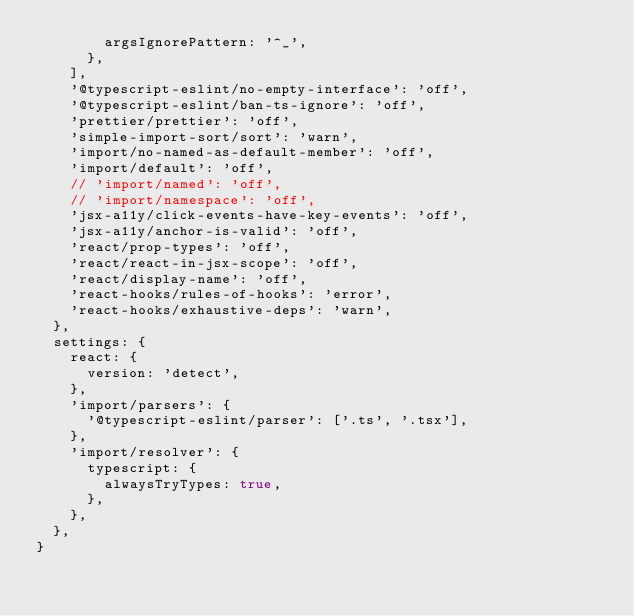Convert code to text. <code><loc_0><loc_0><loc_500><loc_500><_JavaScript_>        argsIgnorePattern: '^_',
      },
    ],
    '@typescript-eslint/no-empty-interface': 'off',
    '@typescript-eslint/ban-ts-ignore': 'off',
    'prettier/prettier': 'off',
    'simple-import-sort/sort': 'warn',
    'import/no-named-as-default-member': 'off',
    'import/default': 'off',
    // 'import/named': 'off',
    // 'import/namespace': 'off',
    'jsx-a11y/click-events-have-key-events': 'off',
    'jsx-a11y/anchor-is-valid': 'off',
    'react/prop-types': 'off',
    'react/react-in-jsx-scope': 'off',
    'react/display-name': 'off',
    'react-hooks/rules-of-hooks': 'error',
    'react-hooks/exhaustive-deps': 'warn',
  },
  settings: {
    react: {
      version: 'detect',
    },
    'import/parsers': {
      '@typescript-eslint/parser': ['.ts', '.tsx'],
    },
    'import/resolver': {
      typescript: {
        alwaysTryTypes: true,
      },
    },
  },
}
</code> 